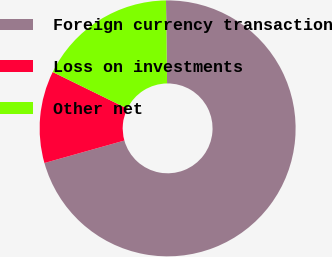Convert chart. <chart><loc_0><loc_0><loc_500><loc_500><pie_chart><fcel>Foreign currency transaction<fcel>Loss on investments<fcel>Other net<nl><fcel>70.84%<fcel>11.62%<fcel>17.54%<nl></chart> 